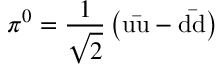Convert formula to latex. <formula><loc_0><loc_0><loc_500><loc_500>\pi ^ { 0 } = { \frac { 1 } { \sqrt { 2 } } } \left ( u { \bar { u } } - d { \bar { d } } \right )</formula> 